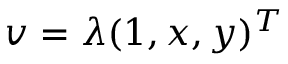<formula> <loc_0><loc_0><loc_500><loc_500>v = \lambda ( 1 , x , y ) ^ { T }</formula> 